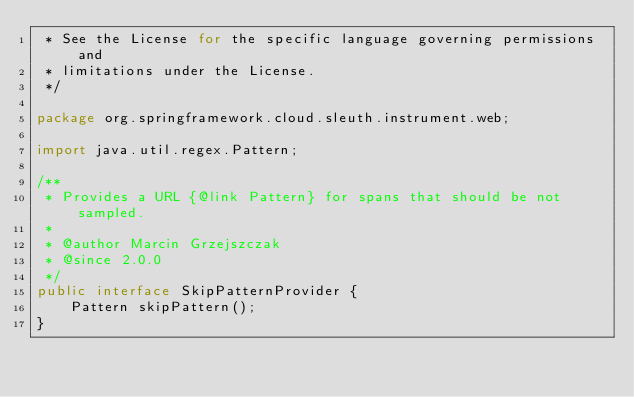Convert code to text. <code><loc_0><loc_0><loc_500><loc_500><_Java_> * See the License for the specific language governing permissions and
 * limitations under the License.
 */

package org.springframework.cloud.sleuth.instrument.web;

import java.util.regex.Pattern;

/**
 * Provides a URL {@link Pattern} for spans that should be not sampled.
 *
 * @author Marcin Grzejszczak
 * @since 2.0.0
 */
public interface SkipPatternProvider {
	Pattern skipPattern();
}
</code> 